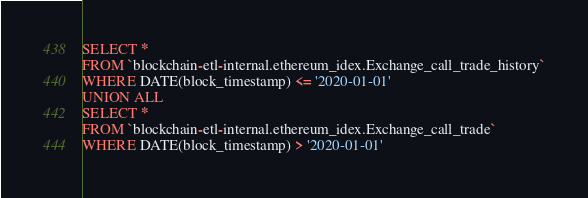<code> <loc_0><loc_0><loc_500><loc_500><_SQL_>SELECT *
FROM `blockchain-etl-internal.ethereum_idex.Exchange_call_trade_history`
WHERE DATE(block_timestamp) <= '2020-01-01'
UNION ALL
SELECT *
FROM `blockchain-etl-internal.ethereum_idex.Exchange_call_trade`
WHERE DATE(block_timestamp) > '2020-01-01'</code> 